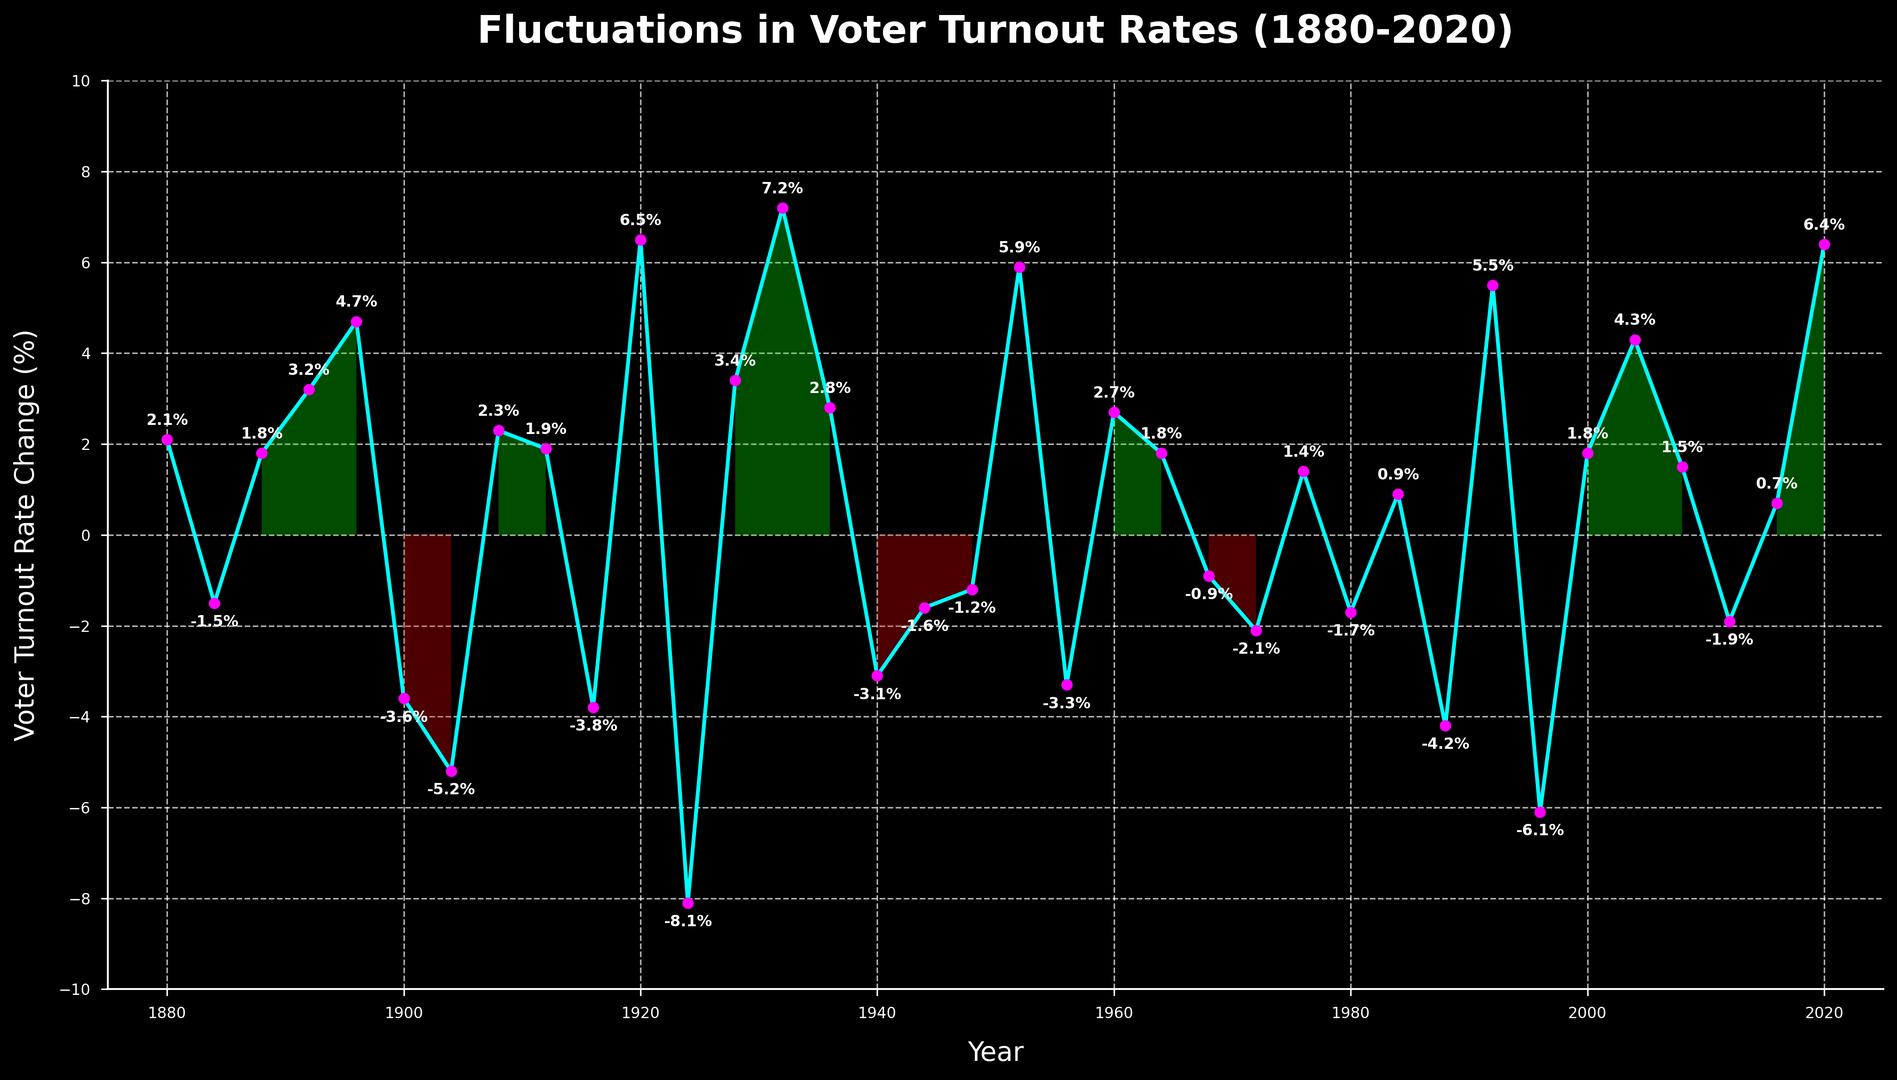Which year had the highest increase in voter turnout rates? The highest increase in voter turnout rates is indicated by the peak point on the graph. In 1932, there is a significant spike to 7.2%.
Answer: 1932 Which year experienced the greatest decline in voter turnout rates? The greatest decline is visible where the line drops the most dramatically. In 1924, voter turnout rates decreased by 8.1%.
Answer: 1924 Compare the voter turnout rate changes between 1928 and 1932. Which year had a higher positive change? 1928 has a 3.4% increase and 1932 shows a 7.2% increase. A comparison of these values shows that 1932 had a higher positive change.
Answer: 1932 What is the average voter turnout rate change for the years 2000 to 2020? To find the average, sum the changes for the years 2000 (1.8%), 2004 (4.3%), 2008 (1.5%), 2012 (-1.9%), 2016 (0.7%), and 2020 (6.4%) and divide by the number of these years: (1.8 + 4.3 + 1.5 - 1.9 + 0.7 + 6.4) / 6 = 2.13%.
Answer: 2.13% During which periods did the voter turnout rates experience continuous decline over two or more consecutive election years? The continuous declines are observed between 1900-1904 (-3.6%, -5.2%) and 1988-1996 (-4.2%, -6.1%).
Answer: 1900-1904 and 1988-1996 How many periods show a sharp increase greater than 5% in voter turnout rates? Sharp increases greater than 5% are seen in 1920 (6.5%), 1932 (7.2%), 1952 (5.9%), and 2020 (6.4%), totaling four periods.
Answer: 4 During which decade did the voter turnout rates show the most fluctuation (both positive and negative changes)? The 1920s show significant fluctuations. Voter turnout rates increased by 6.5% in 1920, decreased by 8.1% in 1924, and increased again by 3.4% in 1928.
Answer: 1920s 